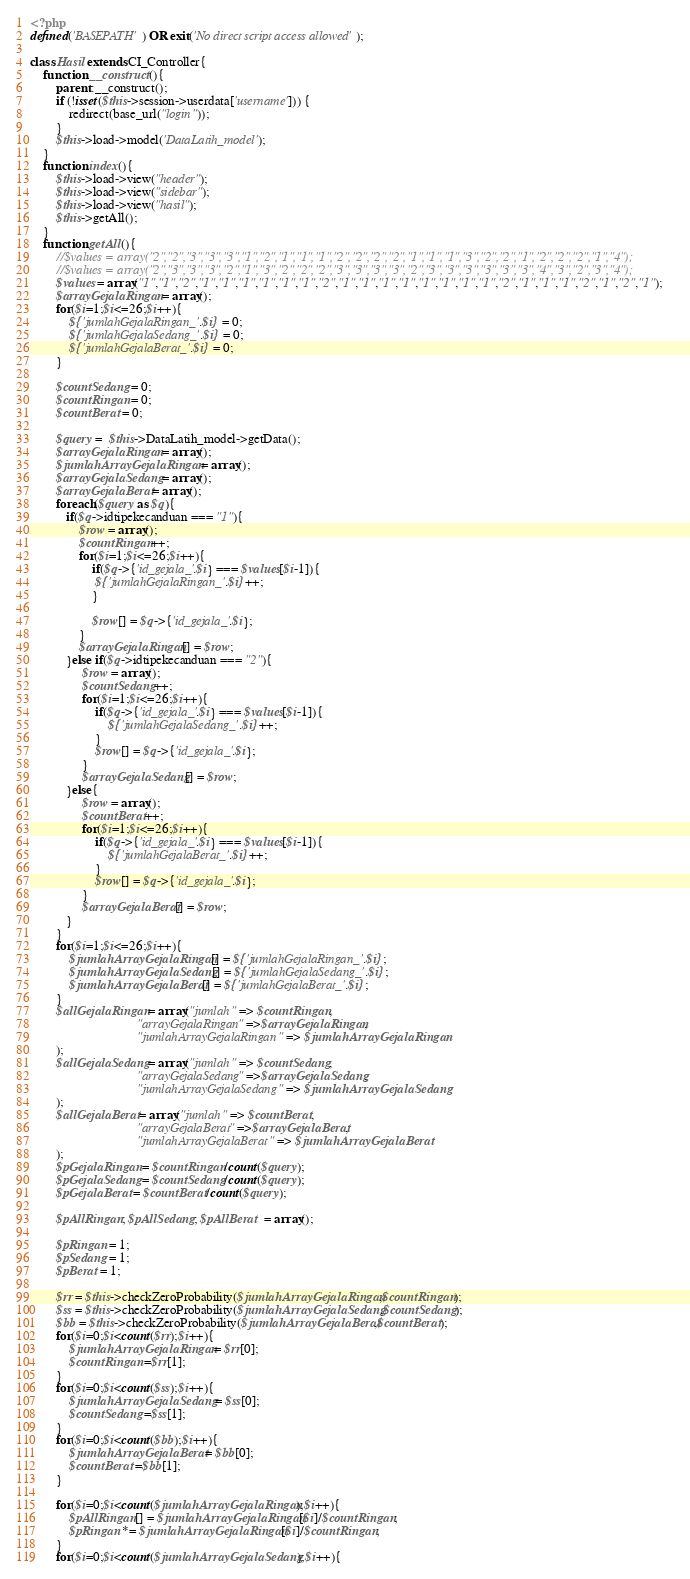<code> <loc_0><loc_0><loc_500><loc_500><_PHP_><?php
defined('BASEPATH') OR exit('No direct script access allowed');

class Hasil extends CI_Controller{
    function __construct(){
        parent::__construct();
        if (!isset($this->session->userdata['username'])) {
			redirect(base_url("login"));
        }
        $this->load->model('DataLatih_model');
    }
    function index(){
        $this->load->view("header");
        $this->load->view("sidebar");
        $this->load->view("hasil");
        $this->getAll();
    }
    function getAll(){
        //$values = array("2","2","3","3","3","1","2","1","1","1","2","2","2","2","1","1","1","3","2","2","1","2","2","2","1","4");
        //$values = array("2","3","3","3","2","1","3","2","2","2","3","3","3","3","2","3","3","3","3","3","3","4","3","2","3","4");
        $values = array("1","1","2","1","1","1","1","1","1","2","1","1","1","1","1","1","1","1","2","1","1","1","2","1","2","1");
        $arrayGejalaRingan = array(); 
        for($i=1;$i<=26;$i++){
            ${'jumlahGejalaRingan_'.$i} = 0;
            ${'jumlahGejalaSedang_'.$i} = 0;
            ${'jumlahGejalaBerat_'.$i} = 0;
        }
        
        $countSedang = 0;
        $countRingan = 0;
        $countBerat = 0;
        
        $query =  $this->DataLatih_model->getData();
        $arrayGejalaRingan = array();
        $jumlahArrayGejalaRingan = array();
        $arrayGejalaSedang = array();
        $arrayGejalaBerat = array();
        foreach($query as $q){
           if($q->idtipekecanduan === "1"){
               $row = array();
               $countRingan++;
               for($i=1;$i<=26;$i++){
                   if($q->{'id_gejala_'.$i} === $values[$i-1]){
                    ${'jumlahGejalaRingan_'.$i}++;
                   }
                   
                   $row[] = $q->{'id_gejala_'.$i};
               }
               $arrayGejalaRingan[] = $row;
           }else if($q->idtipekecanduan === "2"){
                $row = array();
                $countSedang++;
                for($i=1;$i<=26;$i++){
                    if($q->{'id_gejala_'.$i} === $values[$i-1]){
                        ${'jumlahGejalaSedang_'.$i}++;
                    }
                    $row[] = $q->{'id_gejala_'.$i};
                }
                $arrayGejalaSedang[] = $row;
           }else{
                $row = array();
                $countBerat++;
                for($i=1;$i<=26;$i++){
                    if($q->{'id_gejala_'.$i} === $values[$i-1]){
                        ${'jumlahGejalaBerat_'.$i}++;
                    }
                    $row[] = $q->{'id_gejala_'.$i};
                }
                $arrayGejalaBerat[] = $row;
           }
        }
        for($i=1;$i<=26;$i++){
            $jumlahArrayGejalaRingan[] = ${'jumlahGejalaRingan_'.$i};
            $jumlahArrayGejalaSedang[] = ${'jumlahGejalaSedang_'.$i};
            $jumlahArrayGejalaBerat[] = ${'jumlahGejalaBerat_'.$i};
        }
        $allGejalaRingan = array("jumlah" => $countRingan,
                                 "arrayGejalaRingan" =>$arrayGejalaRingan,
                                 "jumlahArrayGejalaRingan" => $jumlahArrayGejalaRingan
        );
        $allGejalaSedang = array("jumlah" => $countSedang,
                                 "arrayGejalaSedang" =>$arrayGejalaSedang,
                                 "jumlahArrayGejalaSedang" => $jumlahArrayGejalaSedang
        );
        $allGejalaBerat = array("jumlah" => $countBerat,
                                 "arrayGejalaBerat" =>$arrayGejalaBerat,
                                 "jumlahArrayGejalaBerat" => $jumlahArrayGejalaBerat
        );
        $pGejalaRingan = $countRingan/count($query);
        $pGejalaSedang = $countSedang/count($query);
        $pGejalaBerat = $countBerat/count($query);
        
        $pAllRingan; $pAllSedang; $pAllBerat  = array();
        
        $pRingan = 1;
        $pSedang = 1;
        $pBerat = 1;

        $rr = $this->checkZeroProbability($jumlahArrayGejalaRingan,$countRingan);
        $ss = $this->checkZeroProbability($jumlahArrayGejalaSedang,$countSedang);
        $bb = $this->checkZeroProbability($jumlahArrayGejalaBerat,$countBerat);
        for($i=0;$i<count($rr);$i++){
            $jumlahArrayGejalaRingan = $rr[0];
            $countRingan =$rr[1];
        }
        for($i=0;$i<count($ss);$i++){
            $jumlahArrayGejalaSedang = $ss[0];
            $countSedang =$ss[1];
        }
        for($i=0;$i<count($bb);$i++){
            $jumlahArrayGejalaBerat = $bb[0];
            $countBerat =$bb[1];
        }
        
        for($i=0;$i<count($jumlahArrayGejalaRingan);$i++){
            $pAllRingan[] = $jumlahArrayGejalaRingan[$i]/$countRingan;
            $pRingan *= $jumlahArrayGejalaRingan[$i]/$countRingan;
        }
        for($i=0;$i<count($jumlahArrayGejalaSedang);$i++){</code> 